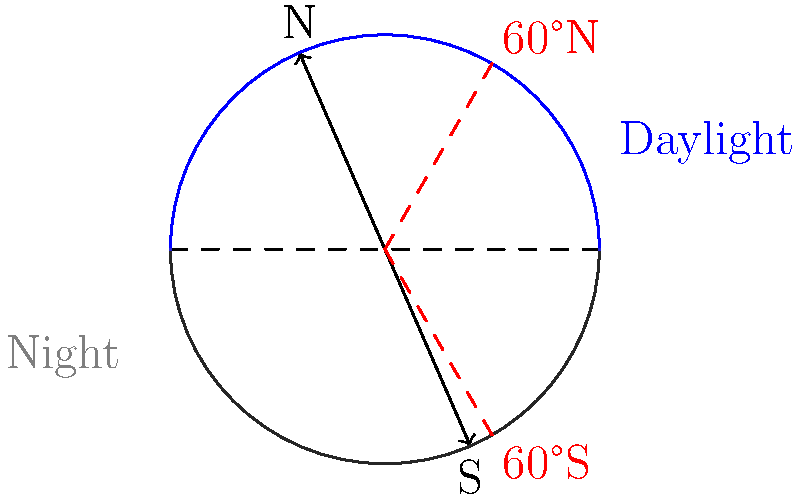As a resident of Bainbridge Island (approximately 47.6°N latitude), you're aware of the significant variations in daylight hours throughout the year. How does the Earth's axial tilt of 23.5° affect the duration of daylight at 60°N latitude compared to the equator during the summer solstice? To understand the effect of Earth's axial tilt on daylight duration, let's follow these steps:

1. Earth's axial tilt:
   The Earth is tilted at an angle of 23.5° relative to its orbital plane.

2. Summer solstice:
   This occurs when the North Pole is tilted most directly towards the Sun (around June 21st).

3. Equator (0° latitude):
   - At the equator, day and night are always approximately equal, each lasting about 12 hours.
   - This is because the equator is always perpendicular to the Sun's rays, regardless of Earth's tilt.

4. 60°N latitude:
   - During the summer solstice, this latitude is tilted towards the Sun.
   - The Arctic Circle (66.5°N) experiences 24 hours of daylight on the summer solstice.
   - At 60°N, which is closer to the Arctic Circle than the equator, the effect is pronounced but not as extreme.

5. Calculating daylight duration at 60°N:
   - The Sun's declination (δ) at summer solstice is 23.5°.
   - Using the daylight duration formula: 
     $$ \text{Hours of daylight} = \frac{24}{\pi} \arccos\left(-\tan(\phi) \tan(\delta)\right) $$
     where $\phi$ is the latitude and $\delta$ is the Sun's declination.
   - For 60°N: $$ \frac{24}{\pi} \arccos\left(-\tan(60°) \tan(23.5°)\right) \approx 18.8 \text{ hours} $$

6. Comparison:
   - Equator: 12 hours of daylight
   - 60°N: approximately 18.8 hours of daylight

The difference in daylight duration is due to the Earth's axial tilt causing the Sun's rays to strike higher latitudes at a more direct angle during the summer solstice, resulting in longer periods of daylight.
Answer: 60°N experiences about 6.8 hours more daylight than the equator during summer solstice. 